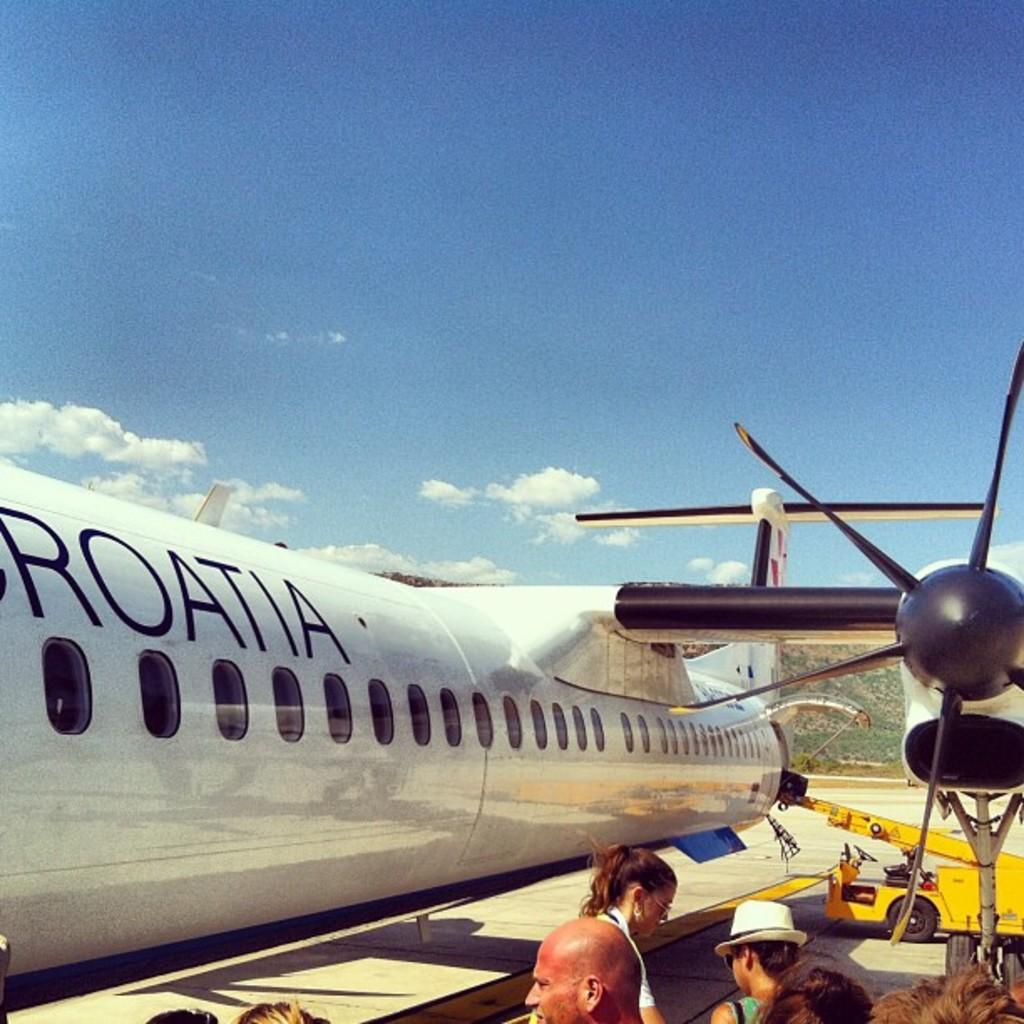<image>
Share a concise interpretation of the image provided. The flight that the people are boarding is arranged by Croatia. 